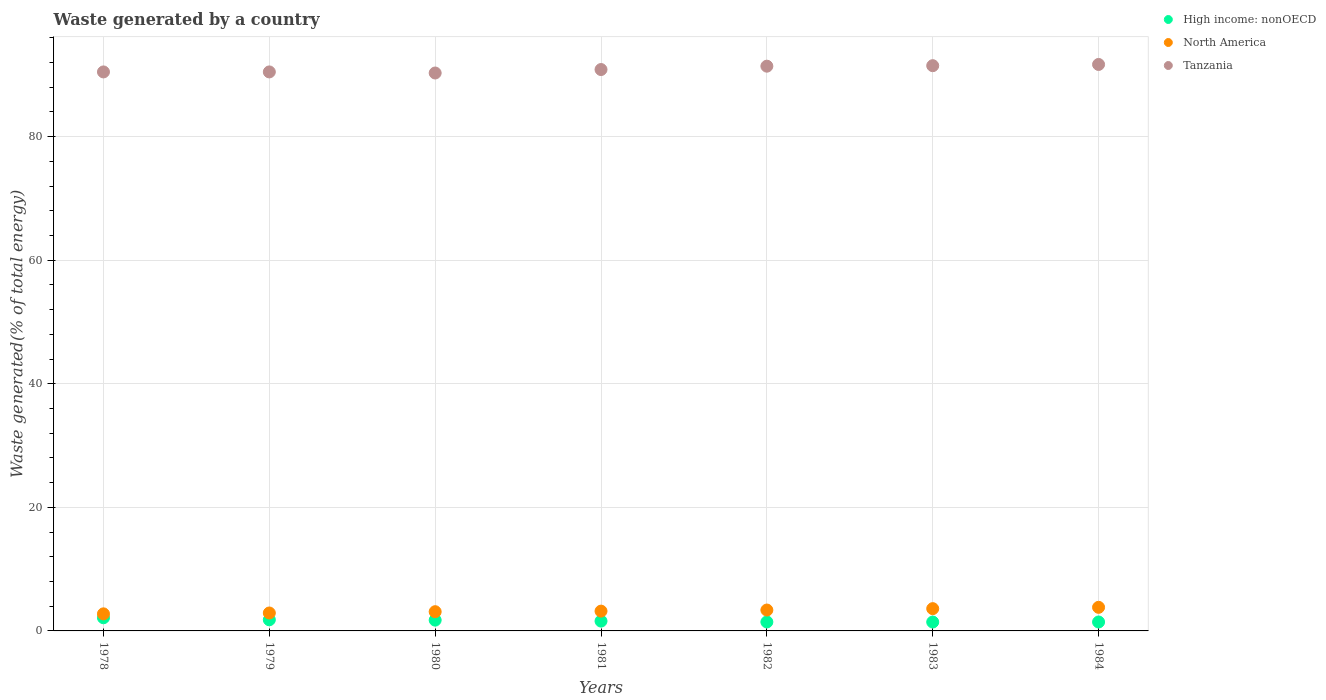How many different coloured dotlines are there?
Offer a very short reply. 3. What is the total waste generated in North America in 1980?
Offer a terse response. 3.11. Across all years, what is the maximum total waste generated in Tanzania?
Give a very brief answer. 91.67. Across all years, what is the minimum total waste generated in Tanzania?
Offer a terse response. 90.29. In which year was the total waste generated in Tanzania maximum?
Make the answer very short. 1984. In which year was the total waste generated in North America minimum?
Make the answer very short. 1978. What is the total total waste generated in Tanzania in the graph?
Ensure brevity in your answer.  636.59. What is the difference between the total waste generated in Tanzania in 1982 and that in 1983?
Keep it short and to the point. -0.08. What is the difference between the total waste generated in North America in 1981 and the total waste generated in Tanzania in 1980?
Offer a terse response. -87.08. What is the average total waste generated in Tanzania per year?
Give a very brief answer. 90.94. In the year 1980, what is the difference between the total waste generated in North America and total waste generated in High income: nonOECD?
Provide a short and direct response. 1.37. What is the ratio of the total waste generated in Tanzania in 1980 to that in 1982?
Provide a short and direct response. 0.99. Is the difference between the total waste generated in North America in 1982 and 1983 greater than the difference between the total waste generated in High income: nonOECD in 1982 and 1983?
Your response must be concise. No. What is the difference between the highest and the second highest total waste generated in Tanzania?
Provide a succinct answer. 0.2. What is the difference between the highest and the lowest total waste generated in Tanzania?
Your response must be concise. 1.38. In how many years, is the total waste generated in High income: nonOECD greater than the average total waste generated in High income: nonOECD taken over all years?
Make the answer very short. 3. Is the sum of the total waste generated in High income: nonOECD in 1982 and 1984 greater than the maximum total waste generated in North America across all years?
Ensure brevity in your answer.  No. Is the total waste generated in Tanzania strictly greater than the total waste generated in North America over the years?
Offer a very short reply. Yes. How many dotlines are there?
Make the answer very short. 3. What is the difference between two consecutive major ticks on the Y-axis?
Provide a short and direct response. 20. Does the graph contain any zero values?
Provide a short and direct response. No. Does the graph contain grids?
Ensure brevity in your answer.  Yes. Where does the legend appear in the graph?
Ensure brevity in your answer.  Top right. How many legend labels are there?
Your answer should be compact. 3. What is the title of the graph?
Your answer should be compact. Waste generated by a country. What is the label or title of the Y-axis?
Offer a very short reply. Waste generated(% of total energy). What is the Waste generated(% of total energy) in High income: nonOECD in 1978?
Provide a short and direct response. 2.13. What is the Waste generated(% of total energy) in North America in 1978?
Your answer should be compact. 2.76. What is the Waste generated(% of total energy) in Tanzania in 1978?
Make the answer very short. 90.46. What is the Waste generated(% of total energy) in High income: nonOECD in 1979?
Provide a short and direct response. 1.8. What is the Waste generated(% of total energy) in North America in 1979?
Keep it short and to the point. 2.9. What is the Waste generated(% of total energy) in Tanzania in 1979?
Give a very brief answer. 90.46. What is the Waste generated(% of total energy) of High income: nonOECD in 1980?
Provide a succinct answer. 1.75. What is the Waste generated(% of total energy) in North America in 1980?
Ensure brevity in your answer.  3.11. What is the Waste generated(% of total energy) of Tanzania in 1980?
Keep it short and to the point. 90.29. What is the Waste generated(% of total energy) of High income: nonOECD in 1981?
Offer a terse response. 1.59. What is the Waste generated(% of total energy) of North America in 1981?
Ensure brevity in your answer.  3.2. What is the Waste generated(% of total energy) of Tanzania in 1981?
Offer a very short reply. 90.85. What is the Waste generated(% of total energy) in High income: nonOECD in 1982?
Offer a very short reply. 1.45. What is the Waste generated(% of total energy) of North America in 1982?
Your answer should be compact. 3.38. What is the Waste generated(% of total energy) in Tanzania in 1982?
Your answer should be compact. 91.39. What is the Waste generated(% of total energy) of High income: nonOECD in 1983?
Make the answer very short. 1.44. What is the Waste generated(% of total energy) of North America in 1983?
Offer a terse response. 3.6. What is the Waste generated(% of total energy) of Tanzania in 1983?
Give a very brief answer. 91.47. What is the Waste generated(% of total energy) of High income: nonOECD in 1984?
Provide a succinct answer. 1.44. What is the Waste generated(% of total energy) in North America in 1984?
Provide a succinct answer. 3.82. What is the Waste generated(% of total energy) in Tanzania in 1984?
Give a very brief answer. 91.67. Across all years, what is the maximum Waste generated(% of total energy) of High income: nonOECD?
Give a very brief answer. 2.13. Across all years, what is the maximum Waste generated(% of total energy) of North America?
Your answer should be very brief. 3.82. Across all years, what is the maximum Waste generated(% of total energy) of Tanzania?
Offer a terse response. 91.67. Across all years, what is the minimum Waste generated(% of total energy) in High income: nonOECD?
Ensure brevity in your answer.  1.44. Across all years, what is the minimum Waste generated(% of total energy) in North America?
Your response must be concise. 2.76. Across all years, what is the minimum Waste generated(% of total energy) in Tanzania?
Give a very brief answer. 90.29. What is the total Waste generated(% of total energy) in High income: nonOECD in the graph?
Offer a very short reply. 11.6. What is the total Waste generated(% of total energy) of North America in the graph?
Provide a succinct answer. 22.78. What is the total Waste generated(% of total energy) in Tanzania in the graph?
Your answer should be very brief. 636.59. What is the difference between the Waste generated(% of total energy) in High income: nonOECD in 1978 and that in 1979?
Offer a very short reply. 0.33. What is the difference between the Waste generated(% of total energy) in North America in 1978 and that in 1979?
Your answer should be compact. -0.14. What is the difference between the Waste generated(% of total energy) of Tanzania in 1978 and that in 1979?
Your answer should be very brief. -0. What is the difference between the Waste generated(% of total energy) in High income: nonOECD in 1978 and that in 1980?
Your response must be concise. 0.38. What is the difference between the Waste generated(% of total energy) of North America in 1978 and that in 1980?
Provide a short and direct response. -0.35. What is the difference between the Waste generated(% of total energy) of Tanzania in 1978 and that in 1980?
Keep it short and to the point. 0.17. What is the difference between the Waste generated(% of total energy) in High income: nonOECD in 1978 and that in 1981?
Offer a terse response. 0.54. What is the difference between the Waste generated(% of total energy) of North America in 1978 and that in 1981?
Ensure brevity in your answer.  -0.44. What is the difference between the Waste generated(% of total energy) in Tanzania in 1978 and that in 1981?
Make the answer very short. -0.39. What is the difference between the Waste generated(% of total energy) in High income: nonOECD in 1978 and that in 1982?
Ensure brevity in your answer.  0.68. What is the difference between the Waste generated(% of total energy) in North America in 1978 and that in 1982?
Provide a short and direct response. -0.62. What is the difference between the Waste generated(% of total energy) of Tanzania in 1978 and that in 1982?
Your response must be concise. -0.93. What is the difference between the Waste generated(% of total energy) in High income: nonOECD in 1978 and that in 1983?
Your answer should be very brief. 0.69. What is the difference between the Waste generated(% of total energy) in North America in 1978 and that in 1983?
Your answer should be very brief. -0.84. What is the difference between the Waste generated(% of total energy) of Tanzania in 1978 and that in 1983?
Make the answer very short. -1.01. What is the difference between the Waste generated(% of total energy) of High income: nonOECD in 1978 and that in 1984?
Your answer should be very brief. 0.68. What is the difference between the Waste generated(% of total energy) of North America in 1978 and that in 1984?
Ensure brevity in your answer.  -1.06. What is the difference between the Waste generated(% of total energy) of Tanzania in 1978 and that in 1984?
Give a very brief answer. -1.21. What is the difference between the Waste generated(% of total energy) of High income: nonOECD in 1979 and that in 1980?
Offer a very short reply. 0.05. What is the difference between the Waste generated(% of total energy) in North America in 1979 and that in 1980?
Offer a very short reply. -0.21. What is the difference between the Waste generated(% of total energy) of Tanzania in 1979 and that in 1980?
Your answer should be compact. 0.17. What is the difference between the Waste generated(% of total energy) of High income: nonOECD in 1979 and that in 1981?
Offer a very short reply. 0.21. What is the difference between the Waste generated(% of total energy) of North America in 1979 and that in 1981?
Your answer should be compact. -0.3. What is the difference between the Waste generated(% of total energy) in Tanzania in 1979 and that in 1981?
Offer a very short reply. -0.39. What is the difference between the Waste generated(% of total energy) in High income: nonOECD in 1979 and that in 1982?
Keep it short and to the point. 0.35. What is the difference between the Waste generated(% of total energy) of North America in 1979 and that in 1982?
Your response must be concise. -0.48. What is the difference between the Waste generated(% of total energy) in Tanzania in 1979 and that in 1982?
Give a very brief answer. -0.93. What is the difference between the Waste generated(% of total energy) of High income: nonOECD in 1979 and that in 1983?
Make the answer very short. 0.36. What is the difference between the Waste generated(% of total energy) in North America in 1979 and that in 1983?
Offer a terse response. -0.7. What is the difference between the Waste generated(% of total energy) in Tanzania in 1979 and that in 1983?
Offer a very short reply. -1.01. What is the difference between the Waste generated(% of total energy) in High income: nonOECD in 1979 and that in 1984?
Provide a short and direct response. 0.36. What is the difference between the Waste generated(% of total energy) of North America in 1979 and that in 1984?
Your answer should be very brief. -0.92. What is the difference between the Waste generated(% of total energy) in Tanzania in 1979 and that in 1984?
Keep it short and to the point. -1.21. What is the difference between the Waste generated(% of total energy) of High income: nonOECD in 1980 and that in 1981?
Keep it short and to the point. 0.16. What is the difference between the Waste generated(% of total energy) in North America in 1980 and that in 1981?
Your response must be concise. -0.09. What is the difference between the Waste generated(% of total energy) of Tanzania in 1980 and that in 1981?
Keep it short and to the point. -0.56. What is the difference between the Waste generated(% of total energy) in High income: nonOECD in 1980 and that in 1982?
Keep it short and to the point. 0.3. What is the difference between the Waste generated(% of total energy) in North America in 1980 and that in 1982?
Provide a succinct answer. -0.27. What is the difference between the Waste generated(% of total energy) in Tanzania in 1980 and that in 1982?
Offer a very short reply. -1.11. What is the difference between the Waste generated(% of total energy) of High income: nonOECD in 1980 and that in 1983?
Provide a succinct answer. 0.31. What is the difference between the Waste generated(% of total energy) in North America in 1980 and that in 1983?
Make the answer very short. -0.49. What is the difference between the Waste generated(% of total energy) in Tanzania in 1980 and that in 1983?
Your answer should be very brief. -1.18. What is the difference between the Waste generated(% of total energy) in High income: nonOECD in 1980 and that in 1984?
Your answer should be very brief. 0.3. What is the difference between the Waste generated(% of total energy) of North America in 1980 and that in 1984?
Offer a terse response. -0.71. What is the difference between the Waste generated(% of total energy) of Tanzania in 1980 and that in 1984?
Provide a succinct answer. -1.38. What is the difference between the Waste generated(% of total energy) of High income: nonOECD in 1981 and that in 1982?
Your response must be concise. 0.14. What is the difference between the Waste generated(% of total energy) of North America in 1981 and that in 1982?
Make the answer very short. -0.18. What is the difference between the Waste generated(% of total energy) of Tanzania in 1981 and that in 1982?
Offer a very short reply. -0.54. What is the difference between the Waste generated(% of total energy) in High income: nonOECD in 1981 and that in 1983?
Give a very brief answer. 0.15. What is the difference between the Waste generated(% of total energy) in North America in 1981 and that in 1983?
Make the answer very short. -0.4. What is the difference between the Waste generated(% of total energy) of Tanzania in 1981 and that in 1983?
Make the answer very short. -0.62. What is the difference between the Waste generated(% of total energy) of High income: nonOECD in 1981 and that in 1984?
Provide a succinct answer. 0.14. What is the difference between the Waste generated(% of total energy) in North America in 1981 and that in 1984?
Your answer should be compact. -0.62. What is the difference between the Waste generated(% of total energy) of Tanzania in 1981 and that in 1984?
Your response must be concise. -0.82. What is the difference between the Waste generated(% of total energy) in High income: nonOECD in 1982 and that in 1983?
Ensure brevity in your answer.  0.01. What is the difference between the Waste generated(% of total energy) in North America in 1982 and that in 1983?
Your answer should be very brief. -0.23. What is the difference between the Waste generated(% of total energy) of Tanzania in 1982 and that in 1983?
Provide a short and direct response. -0.08. What is the difference between the Waste generated(% of total energy) in High income: nonOECD in 1982 and that in 1984?
Your answer should be very brief. 0. What is the difference between the Waste generated(% of total energy) in North America in 1982 and that in 1984?
Provide a short and direct response. -0.44. What is the difference between the Waste generated(% of total energy) of Tanzania in 1982 and that in 1984?
Provide a short and direct response. -0.28. What is the difference between the Waste generated(% of total energy) of High income: nonOECD in 1983 and that in 1984?
Your answer should be very brief. -0.01. What is the difference between the Waste generated(% of total energy) of North America in 1983 and that in 1984?
Your answer should be very brief. -0.21. What is the difference between the Waste generated(% of total energy) in Tanzania in 1983 and that in 1984?
Make the answer very short. -0.2. What is the difference between the Waste generated(% of total energy) of High income: nonOECD in 1978 and the Waste generated(% of total energy) of North America in 1979?
Provide a short and direct response. -0.77. What is the difference between the Waste generated(% of total energy) of High income: nonOECD in 1978 and the Waste generated(% of total energy) of Tanzania in 1979?
Provide a short and direct response. -88.33. What is the difference between the Waste generated(% of total energy) of North America in 1978 and the Waste generated(% of total energy) of Tanzania in 1979?
Offer a very short reply. -87.7. What is the difference between the Waste generated(% of total energy) in High income: nonOECD in 1978 and the Waste generated(% of total energy) in North America in 1980?
Offer a terse response. -0.98. What is the difference between the Waste generated(% of total energy) in High income: nonOECD in 1978 and the Waste generated(% of total energy) in Tanzania in 1980?
Your answer should be very brief. -88.16. What is the difference between the Waste generated(% of total energy) in North America in 1978 and the Waste generated(% of total energy) in Tanzania in 1980?
Offer a terse response. -87.52. What is the difference between the Waste generated(% of total energy) of High income: nonOECD in 1978 and the Waste generated(% of total energy) of North America in 1981?
Offer a terse response. -1.07. What is the difference between the Waste generated(% of total energy) in High income: nonOECD in 1978 and the Waste generated(% of total energy) in Tanzania in 1981?
Your response must be concise. -88.72. What is the difference between the Waste generated(% of total energy) in North America in 1978 and the Waste generated(% of total energy) in Tanzania in 1981?
Your answer should be compact. -88.08. What is the difference between the Waste generated(% of total energy) in High income: nonOECD in 1978 and the Waste generated(% of total energy) in North America in 1982?
Your answer should be compact. -1.25. What is the difference between the Waste generated(% of total energy) of High income: nonOECD in 1978 and the Waste generated(% of total energy) of Tanzania in 1982?
Your answer should be very brief. -89.26. What is the difference between the Waste generated(% of total energy) of North America in 1978 and the Waste generated(% of total energy) of Tanzania in 1982?
Give a very brief answer. -88.63. What is the difference between the Waste generated(% of total energy) of High income: nonOECD in 1978 and the Waste generated(% of total energy) of North America in 1983?
Provide a short and direct response. -1.48. What is the difference between the Waste generated(% of total energy) in High income: nonOECD in 1978 and the Waste generated(% of total energy) in Tanzania in 1983?
Give a very brief answer. -89.34. What is the difference between the Waste generated(% of total energy) in North America in 1978 and the Waste generated(% of total energy) in Tanzania in 1983?
Keep it short and to the point. -88.71. What is the difference between the Waste generated(% of total energy) in High income: nonOECD in 1978 and the Waste generated(% of total energy) in North America in 1984?
Provide a short and direct response. -1.69. What is the difference between the Waste generated(% of total energy) in High income: nonOECD in 1978 and the Waste generated(% of total energy) in Tanzania in 1984?
Provide a succinct answer. -89.54. What is the difference between the Waste generated(% of total energy) in North America in 1978 and the Waste generated(% of total energy) in Tanzania in 1984?
Offer a terse response. -88.91. What is the difference between the Waste generated(% of total energy) of High income: nonOECD in 1979 and the Waste generated(% of total energy) of North America in 1980?
Offer a terse response. -1.31. What is the difference between the Waste generated(% of total energy) in High income: nonOECD in 1979 and the Waste generated(% of total energy) in Tanzania in 1980?
Provide a succinct answer. -88.49. What is the difference between the Waste generated(% of total energy) in North America in 1979 and the Waste generated(% of total energy) in Tanzania in 1980?
Your response must be concise. -87.39. What is the difference between the Waste generated(% of total energy) in High income: nonOECD in 1979 and the Waste generated(% of total energy) in North America in 1981?
Your answer should be very brief. -1.4. What is the difference between the Waste generated(% of total energy) in High income: nonOECD in 1979 and the Waste generated(% of total energy) in Tanzania in 1981?
Your response must be concise. -89.05. What is the difference between the Waste generated(% of total energy) in North America in 1979 and the Waste generated(% of total energy) in Tanzania in 1981?
Offer a very short reply. -87.95. What is the difference between the Waste generated(% of total energy) of High income: nonOECD in 1979 and the Waste generated(% of total energy) of North America in 1982?
Give a very brief answer. -1.58. What is the difference between the Waste generated(% of total energy) of High income: nonOECD in 1979 and the Waste generated(% of total energy) of Tanzania in 1982?
Give a very brief answer. -89.59. What is the difference between the Waste generated(% of total energy) of North America in 1979 and the Waste generated(% of total energy) of Tanzania in 1982?
Make the answer very short. -88.49. What is the difference between the Waste generated(% of total energy) of High income: nonOECD in 1979 and the Waste generated(% of total energy) of North America in 1983?
Offer a very short reply. -1.8. What is the difference between the Waste generated(% of total energy) in High income: nonOECD in 1979 and the Waste generated(% of total energy) in Tanzania in 1983?
Your answer should be compact. -89.67. What is the difference between the Waste generated(% of total energy) of North America in 1979 and the Waste generated(% of total energy) of Tanzania in 1983?
Offer a very short reply. -88.57. What is the difference between the Waste generated(% of total energy) of High income: nonOECD in 1979 and the Waste generated(% of total energy) of North America in 1984?
Make the answer very short. -2.02. What is the difference between the Waste generated(% of total energy) of High income: nonOECD in 1979 and the Waste generated(% of total energy) of Tanzania in 1984?
Your answer should be compact. -89.87. What is the difference between the Waste generated(% of total energy) of North America in 1979 and the Waste generated(% of total energy) of Tanzania in 1984?
Offer a terse response. -88.77. What is the difference between the Waste generated(% of total energy) of High income: nonOECD in 1980 and the Waste generated(% of total energy) of North America in 1981?
Make the answer very short. -1.46. What is the difference between the Waste generated(% of total energy) of High income: nonOECD in 1980 and the Waste generated(% of total energy) of Tanzania in 1981?
Your response must be concise. -89.1. What is the difference between the Waste generated(% of total energy) of North America in 1980 and the Waste generated(% of total energy) of Tanzania in 1981?
Provide a succinct answer. -87.74. What is the difference between the Waste generated(% of total energy) of High income: nonOECD in 1980 and the Waste generated(% of total energy) of North America in 1982?
Provide a succinct answer. -1.63. What is the difference between the Waste generated(% of total energy) of High income: nonOECD in 1980 and the Waste generated(% of total energy) of Tanzania in 1982?
Keep it short and to the point. -89.65. What is the difference between the Waste generated(% of total energy) in North America in 1980 and the Waste generated(% of total energy) in Tanzania in 1982?
Your answer should be very brief. -88.28. What is the difference between the Waste generated(% of total energy) of High income: nonOECD in 1980 and the Waste generated(% of total energy) of North America in 1983?
Offer a very short reply. -1.86. What is the difference between the Waste generated(% of total energy) of High income: nonOECD in 1980 and the Waste generated(% of total energy) of Tanzania in 1983?
Give a very brief answer. -89.73. What is the difference between the Waste generated(% of total energy) of North America in 1980 and the Waste generated(% of total energy) of Tanzania in 1983?
Provide a succinct answer. -88.36. What is the difference between the Waste generated(% of total energy) in High income: nonOECD in 1980 and the Waste generated(% of total energy) in North America in 1984?
Your answer should be very brief. -2.07. What is the difference between the Waste generated(% of total energy) of High income: nonOECD in 1980 and the Waste generated(% of total energy) of Tanzania in 1984?
Offer a very short reply. -89.92. What is the difference between the Waste generated(% of total energy) of North America in 1980 and the Waste generated(% of total energy) of Tanzania in 1984?
Your answer should be compact. -88.56. What is the difference between the Waste generated(% of total energy) in High income: nonOECD in 1981 and the Waste generated(% of total energy) in North America in 1982?
Your response must be concise. -1.79. What is the difference between the Waste generated(% of total energy) of High income: nonOECD in 1981 and the Waste generated(% of total energy) of Tanzania in 1982?
Keep it short and to the point. -89.8. What is the difference between the Waste generated(% of total energy) in North America in 1981 and the Waste generated(% of total energy) in Tanzania in 1982?
Provide a short and direct response. -88.19. What is the difference between the Waste generated(% of total energy) in High income: nonOECD in 1981 and the Waste generated(% of total energy) in North America in 1983?
Your answer should be very brief. -2.01. What is the difference between the Waste generated(% of total energy) in High income: nonOECD in 1981 and the Waste generated(% of total energy) in Tanzania in 1983?
Provide a short and direct response. -89.88. What is the difference between the Waste generated(% of total energy) in North America in 1981 and the Waste generated(% of total energy) in Tanzania in 1983?
Make the answer very short. -88.27. What is the difference between the Waste generated(% of total energy) of High income: nonOECD in 1981 and the Waste generated(% of total energy) of North America in 1984?
Make the answer very short. -2.23. What is the difference between the Waste generated(% of total energy) of High income: nonOECD in 1981 and the Waste generated(% of total energy) of Tanzania in 1984?
Offer a terse response. -90.08. What is the difference between the Waste generated(% of total energy) of North America in 1981 and the Waste generated(% of total energy) of Tanzania in 1984?
Your answer should be compact. -88.47. What is the difference between the Waste generated(% of total energy) in High income: nonOECD in 1982 and the Waste generated(% of total energy) in North America in 1983?
Your response must be concise. -2.16. What is the difference between the Waste generated(% of total energy) in High income: nonOECD in 1982 and the Waste generated(% of total energy) in Tanzania in 1983?
Ensure brevity in your answer.  -90.02. What is the difference between the Waste generated(% of total energy) in North America in 1982 and the Waste generated(% of total energy) in Tanzania in 1983?
Give a very brief answer. -88.09. What is the difference between the Waste generated(% of total energy) of High income: nonOECD in 1982 and the Waste generated(% of total energy) of North America in 1984?
Provide a succinct answer. -2.37. What is the difference between the Waste generated(% of total energy) of High income: nonOECD in 1982 and the Waste generated(% of total energy) of Tanzania in 1984?
Your response must be concise. -90.22. What is the difference between the Waste generated(% of total energy) of North America in 1982 and the Waste generated(% of total energy) of Tanzania in 1984?
Offer a very short reply. -88.29. What is the difference between the Waste generated(% of total energy) in High income: nonOECD in 1983 and the Waste generated(% of total energy) in North America in 1984?
Keep it short and to the point. -2.38. What is the difference between the Waste generated(% of total energy) of High income: nonOECD in 1983 and the Waste generated(% of total energy) of Tanzania in 1984?
Provide a succinct answer. -90.23. What is the difference between the Waste generated(% of total energy) in North America in 1983 and the Waste generated(% of total energy) in Tanzania in 1984?
Your response must be concise. -88.07. What is the average Waste generated(% of total energy) in High income: nonOECD per year?
Make the answer very short. 1.66. What is the average Waste generated(% of total energy) in North America per year?
Provide a succinct answer. 3.25. What is the average Waste generated(% of total energy) of Tanzania per year?
Your response must be concise. 90.94. In the year 1978, what is the difference between the Waste generated(% of total energy) of High income: nonOECD and Waste generated(% of total energy) of North America?
Make the answer very short. -0.63. In the year 1978, what is the difference between the Waste generated(% of total energy) in High income: nonOECD and Waste generated(% of total energy) in Tanzania?
Provide a short and direct response. -88.33. In the year 1978, what is the difference between the Waste generated(% of total energy) of North America and Waste generated(% of total energy) of Tanzania?
Keep it short and to the point. -87.7. In the year 1979, what is the difference between the Waste generated(% of total energy) of High income: nonOECD and Waste generated(% of total energy) of North America?
Keep it short and to the point. -1.1. In the year 1979, what is the difference between the Waste generated(% of total energy) in High income: nonOECD and Waste generated(% of total energy) in Tanzania?
Your response must be concise. -88.66. In the year 1979, what is the difference between the Waste generated(% of total energy) in North America and Waste generated(% of total energy) in Tanzania?
Your answer should be compact. -87.56. In the year 1980, what is the difference between the Waste generated(% of total energy) of High income: nonOECD and Waste generated(% of total energy) of North America?
Your response must be concise. -1.37. In the year 1980, what is the difference between the Waste generated(% of total energy) in High income: nonOECD and Waste generated(% of total energy) in Tanzania?
Your answer should be compact. -88.54. In the year 1980, what is the difference between the Waste generated(% of total energy) of North America and Waste generated(% of total energy) of Tanzania?
Your answer should be very brief. -87.17. In the year 1981, what is the difference between the Waste generated(% of total energy) of High income: nonOECD and Waste generated(% of total energy) of North America?
Give a very brief answer. -1.61. In the year 1981, what is the difference between the Waste generated(% of total energy) in High income: nonOECD and Waste generated(% of total energy) in Tanzania?
Offer a terse response. -89.26. In the year 1981, what is the difference between the Waste generated(% of total energy) of North America and Waste generated(% of total energy) of Tanzania?
Your response must be concise. -87.64. In the year 1982, what is the difference between the Waste generated(% of total energy) in High income: nonOECD and Waste generated(% of total energy) in North America?
Your response must be concise. -1.93. In the year 1982, what is the difference between the Waste generated(% of total energy) in High income: nonOECD and Waste generated(% of total energy) in Tanzania?
Offer a very short reply. -89.94. In the year 1982, what is the difference between the Waste generated(% of total energy) in North America and Waste generated(% of total energy) in Tanzania?
Give a very brief answer. -88.01. In the year 1983, what is the difference between the Waste generated(% of total energy) in High income: nonOECD and Waste generated(% of total energy) in North America?
Your response must be concise. -2.17. In the year 1983, what is the difference between the Waste generated(% of total energy) of High income: nonOECD and Waste generated(% of total energy) of Tanzania?
Your response must be concise. -90.03. In the year 1983, what is the difference between the Waste generated(% of total energy) in North America and Waste generated(% of total energy) in Tanzania?
Ensure brevity in your answer.  -87.87. In the year 1984, what is the difference between the Waste generated(% of total energy) of High income: nonOECD and Waste generated(% of total energy) of North America?
Your answer should be very brief. -2.37. In the year 1984, what is the difference between the Waste generated(% of total energy) in High income: nonOECD and Waste generated(% of total energy) in Tanzania?
Keep it short and to the point. -90.23. In the year 1984, what is the difference between the Waste generated(% of total energy) of North America and Waste generated(% of total energy) of Tanzania?
Ensure brevity in your answer.  -87.85. What is the ratio of the Waste generated(% of total energy) in High income: nonOECD in 1978 to that in 1979?
Ensure brevity in your answer.  1.18. What is the ratio of the Waste generated(% of total energy) of North America in 1978 to that in 1979?
Provide a succinct answer. 0.95. What is the ratio of the Waste generated(% of total energy) in High income: nonOECD in 1978 to that in 1980?
Provide a succinct answer. 1.22. What is the ratio of the Waste generated(% of total energy) of North America in 1978 to that in 1980?
Give a very brief answer. 0.89. What is the ratio of the Waste generated(% of total energy) in Tanzania in 1978 to that in 1980?
Offer a terse response. 1. What is the ratio of the Waste generated(% of total energy) of High income: nonOECD in 1978 to that in 1981?
Ensure brevity in your answer.  1.34. What is the ratio of the Waste generated(% of total energy) of North America in 1978 to that in 1981?
Provide a succinct answer. 0.86. What is the ratio of the Waste generated(% of total energy) of Tanzania in 1978 to that in 1981?
Offer a very short reply. 1. What is the ratio of the Waste generated(% of total energy) in High income: nonOECD in 1978 to that in 1982?
Your response must be concise. 1.47. What is the ratio of the Waste generated(% of total energy) of North America in 1978 to that in 1982?
Ensure brevity in your answer.  0.82. What is the ratio of the Waste generated(% of total energy) in Tanzania in 1978 to that in 1982?
Give a very brief answer. 0.99. What is the ratio of the Waste generated(% of total energy) of High income: nonOECD in 1978 to that in 1983?
Offer a very short reply. 1.48. What is the ratio of the Waste generated(% of total energy) in North America in 1978 to that in 1983?
Offer a terse response. 0.77. What is the ratio of the Waste generated(% of total energy) of Tanzania in 1978 to that in 1983?
Your answer should be compact. 0.99. What is the ratio of the Waste generated(% of total energy) in High income: nonOECD in 1978 to that in 1984?
Give a very brief answer. 1.47. What is the ratio of the Waste generated(% of total energy) in North America in 1978 to that in 1984?
Offer a very short reply. 0.72. What is the ratio of the Waste generated(% of total energy) of Tanzania in 1978 to that in 1984?
Make the answer very short. 0.99. What is the ratio of the Waste generated(% of total energy) of High income: nonOECD in 1979 to that in 1980?
Ensure brevity in your answer.  1.03. What is the ratio of the Waste generated(% of total energy) in North America in 1979 to that in 1980?
Ensure brevity in your answer.  0.93. What is the ratio of the Waste generated(% of total energy) of Tanzania in 1979 to that in 1980?
Offer a terse response. 1. What is the ratio of the Waste generated(% of total energy) in High income: nonOECD in 1979 to that in 1981?
Your answer should be compact. 1.13. What is the ratio of the Waste generated(% of total energy) in North America in 1979 to that in 1981?
Your response must be concise. 0.91. What is the ratio of the Waste generated(% of total energy) in Tanzania in 1979 to that in 1981?
Your response must be concise. 1. What is the ratio of the Waste generated(% of total energy) in High income: nonOECD in 1979 to that in 1982?
Your answer should be compact. 1.24. What is the ratio of the Waste generated(% of total energy) of North America in 1979 to that in 1982?
Offer a terse response. 0.86. What is the ratio of the Waste generated(% of total energy) of High income: nonOECD in 1979 to that in 1983?
Provide a succinct answer. 1.25. What is the ratio of the Waste generated(% of total energy) of North America in 1979 to that in 1983?
Keep it short and to the point. 0.8. What is the ratio of the Waste generated(% of total energy) of Tanzania in 1979 to that in 1983?
Your answer should be compact. 0.99. What is the ratio of the Waste generated(% of total energy) in High income: nonOECD in 1979 to that in 1984?
Make the answer very short. 1.25. What is the ratio of the Waste generated(% of total energy) in North America in 1979 to that in 1984?
Give a very brief answer. 0.76. What is the ratio of the Waste generated(% of total energy) of High income: nonOECD in 1980 to that in 1981?
Your answer should be very brief. 1.1. What is the ratio of the Waste generated(% of total energy) of North America in 1980 to that in 1981?
Your response must be concise. 0.97. What is the ratio of the Waste generated(% of total energy) of Tanzania in 1980 to that in 1981?
Offer a terse response. 0.99. What is the ratio of the Waste generated(% of total energy) of High income: nonOECD in 1980 to that in 1982?
Offer a terse response. 1.21. What is the ratio of the Waste generated(% of total energy) of North America in 1980 to that in 1982?
Your answer should be compact. 0.92. What is the ratio of the Waste generated(% of total energy) in Tanzania in 1980 to that in 1982?
Your answer should be compact. 0.99. What is the ratio of the Waste generated(% of total energy) of High income: nonOECD in 1980 to that in 1983?
Ensure brevity in your answer.  1.21. What is the ratio of the Waste generated(% of total energy) of North America in 1980 to that in 1983?
Offer a very short reply. 0.86. What is the ratio of the Waste generated(% of total energy) in High income: nonOECD in 1980 to that in 1984?
Your answer should be very brief. 1.21. What is the ratio of the Waste generated(% of total energy) of North America in 1980 to that in 1984?
Keep it short and to the point. 0.81. What is the ratio of the Waste generated(% of total energy) of Tanzania in 1980 to that in 1984?
Provide a short and direct response. 0.98. What is the ratio of the Waste generated(% of total energy) of High income: nonOECD in 1981 to that in 1982?
Make the answer very short. 1.1. What is the ratio of the Waste generated(% of total energy) in North America in 1981 to that in 1982?
Provide a succinct answer. 0.95. What is the ratio of the Waste generated(% of total energy) of High income: nonOECD in 1981 to that in 1983?
Your answer should be compact. 1.11. What is the ratio of the Waste generated(% of total energy) of North America in 1981 to that in 1983?
Your response must be concise. 0.89. What is the ratio of the Waste generated(% of total energy) in Tanzania in 1981 to that in 1983?
Your answer should be compact. 0.99. What is the ratio of the Waste generated(% of total energy) of High income: nonOECD in 1981 to that in 1984?
Make the answer very short. 1.1. What is the ratio of the Waste generated(% of total energy) in North America in 1981 to that in 1984?
Offer a terse response. 0.84. What is the ratio of the Waste generated(% of total energy) in High income: nonOECD in 1982 to that in 1983?
Give a very brief answer. 1.01. What is the ratio of the Waste generated(% of total energy) of North America in 1982 to that in 1983?
Ensure brevity in your answer.  0.94. What is the ratio of the Waste generated(% of total energy) of North America in 1982 to that in 1984?
Keep it short and to the point. 0.88. What is the ratio of the Waste generated(% of total energy) in Tanzania in 1982 to that in 1984?
Offer a very short reply. 1. What is the ratio of the Waste generated(% of total energy) of High income: nonOECD in 1983 to that in 1984?
Offer a terse response. 1. What is the ratio of the Waste generated(% of total energy) of North America in 1983 to that in 1984?
Offer a terse response. 0.94. What is the difference between the highest and the second highest Waste generated(% of total energy) in High income: nonOECD?
Ensure brevity in your answer.  0.33. What is the difference between the highest and the second highest Waste generated(% of total energy) in North America?
Provide a succinct answer. 0.21. What is the difference between the highest and the second highest Waste generated(% of total energy) of Tanzania?
Your response must be concise. 0.2. What is the difference between the highest and the lowest Waste generated(% of total energy) in High income: nonOECD?
Your answer should be very brief. 0.69. What is the difference between the highest and the lowest Waste generated(% of total energy) of North America?
Provide a short and direct response. 1.06. What is the difference between the highest and the lowest Waste generated(% of total energy) in Tanzania?
Give a very brief answer. 1.38. 